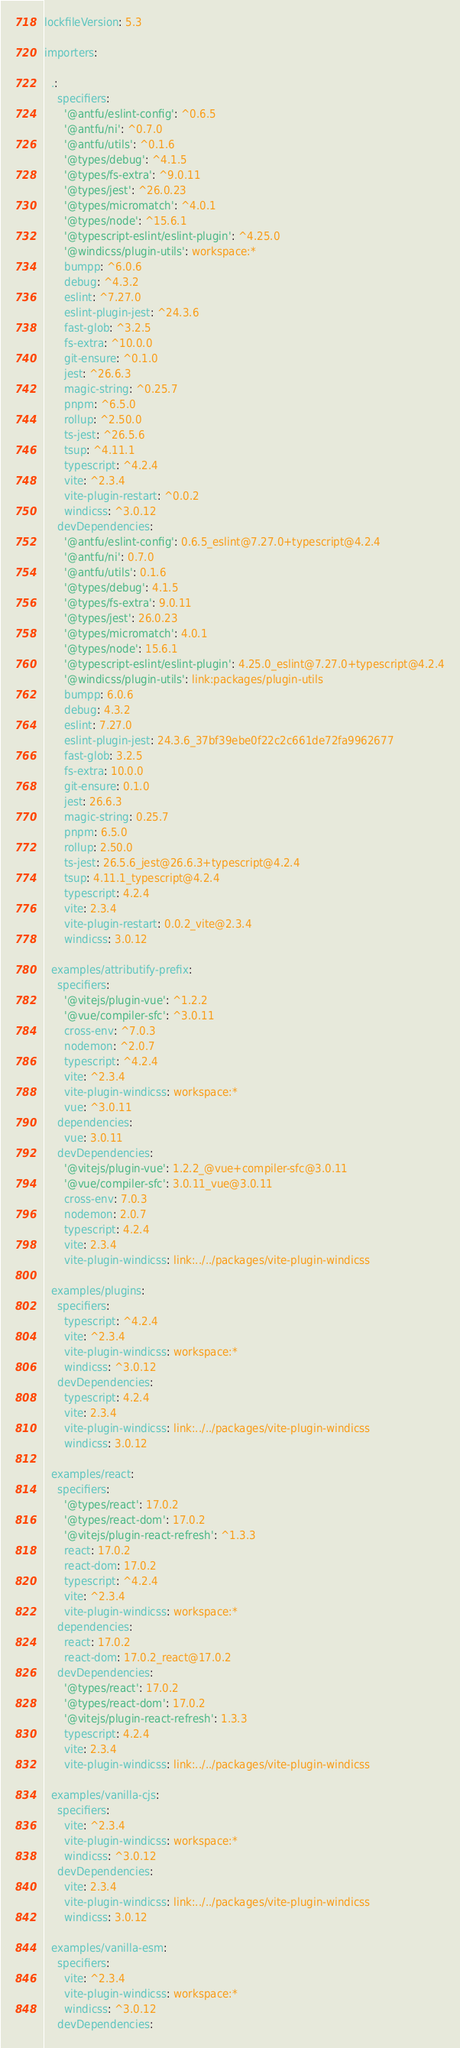Convert code to text. <code><loc_0><loc_0><loc_500><loc_500><_YAML_>lockfileVersion: 5.3

importers:

  .:
    specifiers:
      '@antfu/eslint-config': ^0.6.5
      '@antfu/ni': ^0.7.0
      '@antfu/utils': ^0.1.6
      '@types/debug': ^4.1.5
      '@types/fs-extra': ^9.0.11
      '@types/jest': ^26.0.23
      '@types/micromatch': ^4.0.1
      '@types/node': ^15.6.1
      '@typescript-eslint/eslint-plugin': ^4.25.0
      '@windicss/plugin-utils': workspace:*
      bumpp: ^6.0.6
      debug: ^4.3.2
      eslint: ^7.27.0
      eslint-plugin-jest: ^24.3.6
      fast-glob: ^3.2.5
      fs-extra: ^10.0.0
      git-ensure: ^0.1.0
      jest: ^26.6.3
      magic-string: ^0.25.7
      pnpm: ^6.5.0
      rollup: ^2.50.0
      ts-jest: ^26.5.6
      tsup: ^4.11.1
      typescript: ^4.2.4
      vite: ^2.3.4
      vite-plugin-restart: ^0.0.2
      windicss: ^3.0.12
    devDependencies:
      '@antfu/eslint-config': 0.6.5_eslint@7.27.0+typescript@4.2.4
      '@antfu/ni': 0.7.0
      '@antfu/utils': 0.1.6
      '@types/debug': 4.1.5
      '@types/fs-extra': 9.0.11
      '@types/jest': 26.0.23
      '@types/micromatch': 4.0.1
      '@types/node': 15.6.1
      '@typescript-eslint/eslint-plugin': 4.25.0_eslint@7.27.0+typescript@4.2.4
      '@windicss/plugin-utils': link:packages/plugin-utils
      bumpp: 6.0.6
      debug: 4.3.2
      eslint: 7.27.0
      eslint-plugin-jest: 24.3.6_37bf39ebe0f22c2c661de72fa9962677
      fast-glob: 3.2.5
      fs-extra: 10.0.0
      git-ensure: 0.1.0
      jest: 26.6.3
      magic-string: 0.25.7
      pnpm: 6.5.0
      rollup: 2.50.0
      ts-jest: 26.5.6_jest@26.6.3+typescript@4.2.4
      tsup: 4.11.1_typescript@4.2.4
      typescript: 4.2.4
      vite: 2.3.4
      vite-plugin-restart: 0.0.2_vite@2.3.4
      windicss: 3.0.12

  examples/attributify-prefix:
    specifiers:
      '@vitejs/plugin-vue': ^1.2.2
      '@vue/compiler-sfc': ^3.0.11
      cross-env: ^7.0.3
      nodemon: ^2.0.7
      typescript: ^4.2.4
      vite: ^2.3.4
      vite-plugin-windicss: workspace:*
      vue: ^3.0.11
    dependencies:
      vue: 3.0.11
    devDependencies:
      '@vitejs/plugin-vue': 1.2.2_@vue+compiler-sfc@3.0.11
      '@vue/compiler-sfc': 3.0.11_vue@3.0.11
      cross-env: 7.0.3
      nodemon: 2.0.7
      typescript: 4.2.4
      vite: 2.3.4
      vite-plugin-windicss: link:../../packages/vite-plugin-windicss

  examples/plugins:
    specifiers:
      typescript: ^4.2.4
      vite: ^2.3.4
      vite-plugin-windicss: workspace:*
      windicss: ^3.0.12
    devDependencies:
      typescript: 4.2.4
      vite: 2.3.4
      vite-plugin-windicss: link:../../packages/vite-plugin-windicss
      windicss: 3.0.12

  examples/react:
    specifiers:
      '@types/react': 17.0.2
      '@types/react-dom': 17.0.2
      '@vitejs/plugin-react-refresh': ^1.3.3
      react: 17.0.2
      react-dom: 17.0.2
      typescript: ^4.2.4
      vite: ^2.3.4
      vite-plugin-windicss: workspace:*
    dependencies:
      react: 17.0.2
      react-dom: 17.0.2_react@17.0.2
    devDependencies:
      '@types/react': 17.0.2
      '@types/react-dom': 17.0.2
      '@vitejs/plugin-react-refresh': 1.3.3
      typescript: 4.2.4
      vite: 2.3.4
      vite-plugin-windicss: link:../../packages/vite-plugin-windicss

  examples/vanilla-cjs:
    specifiers:
      vite: ^2.3.4
      vite-plugin-windicss: workspace:*
      windicss: ^3.0.12
    devDependencies:
      vite: 2.3.4
      vite-plugin-windicss: link:../../packages/vite-plugin-windicss
      windicss: 3.0.12

  examples/vanilla-esm:
    specifiers:
      vite: ^2.3.4
      vite-plugin-windicss: workspace:*
      windicss: ^3.0.12
    devDependencies:</code> 